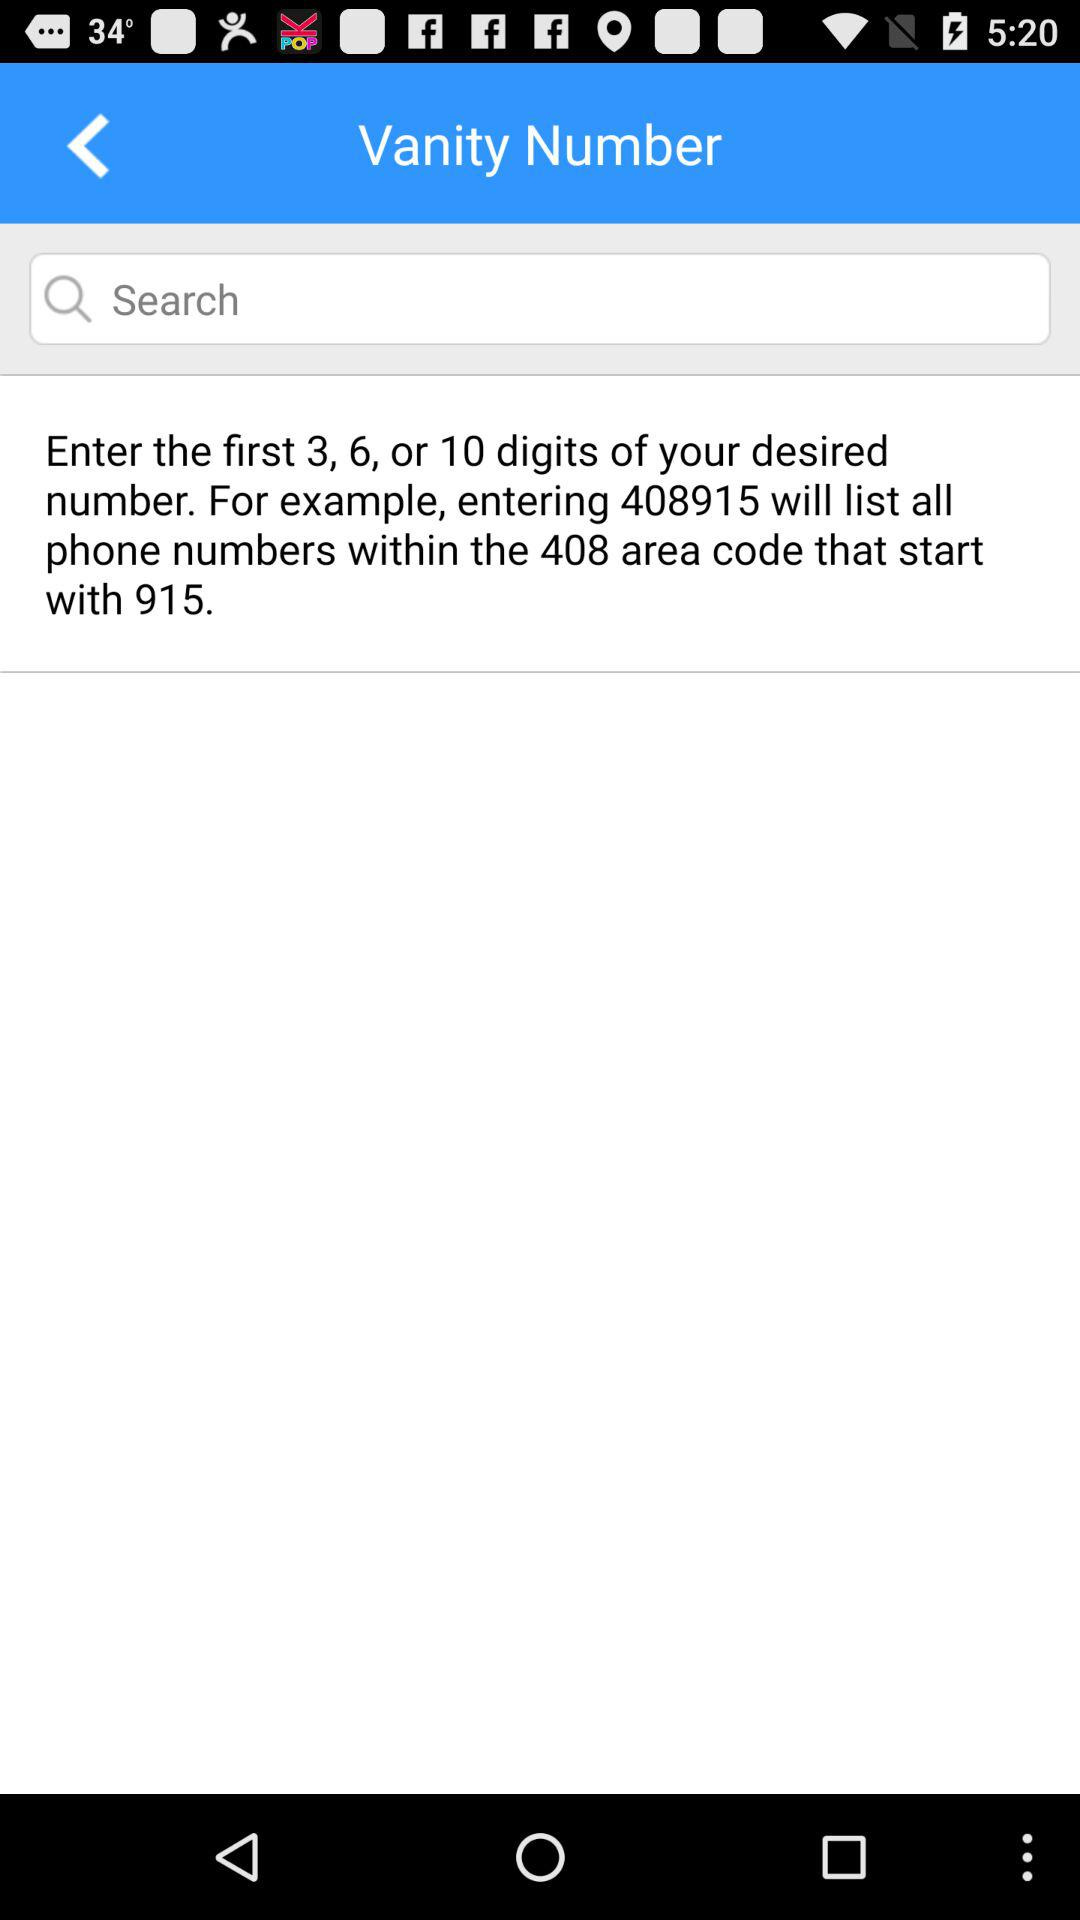How much numbers are desired?
When the provided information is insufficient, respond with <no answer>. <no answer> 